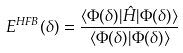<formula> <loc_0><loc_0><loc_500><loc_500>E ^ { H F B } ( \delta ) = \frac { \langle \Phi ( \delta ) | \hat { H } | \Phi ( \delta ) \rangle } { \langle \Phi ( \delta ) | \Phi ( \delta ) \rangle }</formula> 